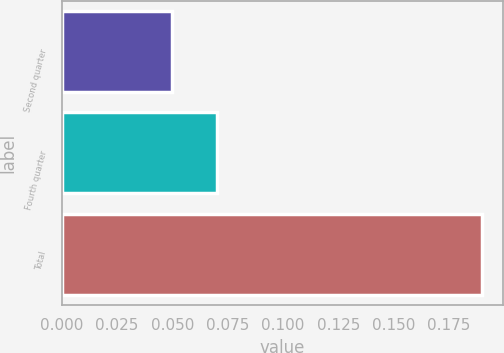<chart> <loc_0><loc_0><loc_500><loc_500><bar_chart><fcel>Second quarter<fcel>Fourth quarter<fcel>Total<nl><fcel>0.05<fcel>0.07<fcel>0.19<nl></chart> 